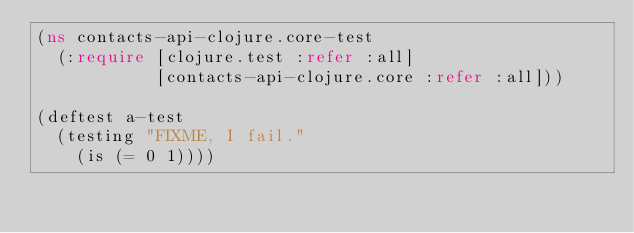Convert code to text. <code><loc_0><loc_0><loc_500><loc_500><_Clojure_>(ns contacts-api-clojure.core-test
  (:require [clojure.test :refer :all]
            [contacts-api-clojure.core :refer :all]))

(deftest a-test
  (testing "FIXME, I fail."
    (is (= 0 1))))
</code> 